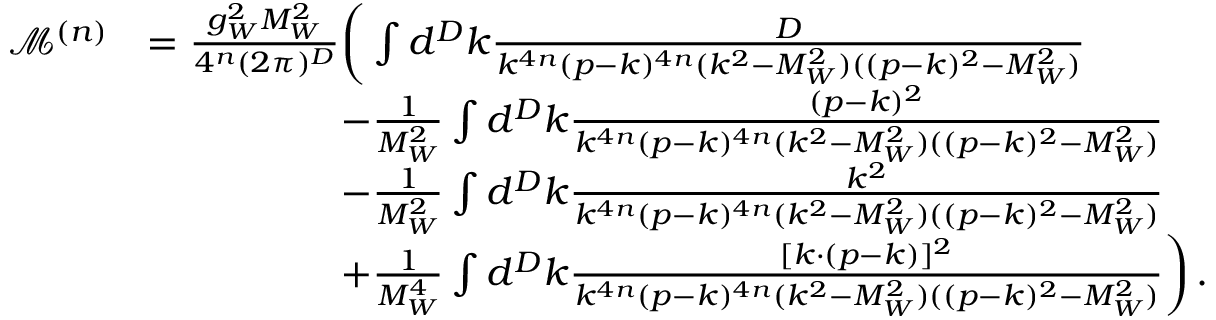Convert formula to latex. <formula><loc_0><loc_0><loc_500><loc_500>\begin{array} { r l } { \mathcal { M } ^ { ( n ) } } & { = \frac { g _ { W } ^ { 2 } M _ { W } ^ { 2 } } { 4 ^ { n } ( 2 \pi ) ^ { D } } \left ( \int d ^ { D } k \frac { D } { k ^ { 4 n } ( p - k ) ^ { 4 n } ( k ^ { 2 } - M _ { W } ^ { 2 } ) ( ( p - k ) ^ { 2 } - M _ { W } ^ { 2 } ) } } \\ & { \quad - \frac { 1 } { M _ { W } ^ { 2 } } \int d ^ { D } k \frac { ( p - k ) ^ { 2 } } { k ^ { 4 n } ( p - k ) ^ { 4 n } ( k ^ { 2 } - M _ { W } ^ { 2 } ) ( ( p - k ) ^ { 2 } - M _ { W } ^ { 2 } ) } } \\ & { \quad - \frac { 1 } { M _ { W } ^ { 2 } } \int d ^ { D } k \frac { k ^ { 2 } } { k ^ { 4 n } ( p - k ) ^ { 4 n } ( k ^ { 2 } - M _ { W } ^ { 2 } ) ( ( p - k ) ^ { 2 } - M _ { W } ^ { 2 } ) } } \\ & { \quad + \frac { 1 } { M _ { W } ^ { 4 } } \int d ^ { D } k \frac { [ k \cdot ( p - k ) ] ^ { 2 } } { k ^ { 4 n } ( p - k ) ^ { 4 n } ( k ^ { 2 } - M _ { W } ^ { 2 } ) ( ( p - k ) ^ { 2 } - M _ { W } ^ { 2 } ) } \right ) \, . } \end{array}</formula> 